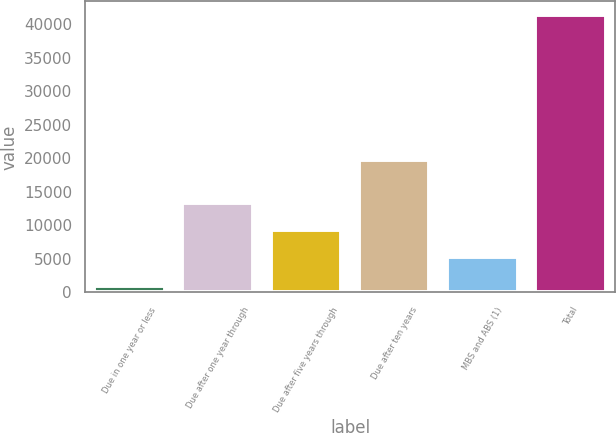Convert chart to OTSL. <chart><loc_0><loc_0><loc_500><loc_500><bar_chart><fcel>Due in one year or less<fcel>Due after one year through<fcel>Due after five years through<fcel>Due after ten years<fcel>MBS and ABS (1)<fcel>Total<nl><fcel>963<fcel>13280.6<fcel>9241.8<fcel>19676<fcel>5203<fcel>41351<nl></chart> 